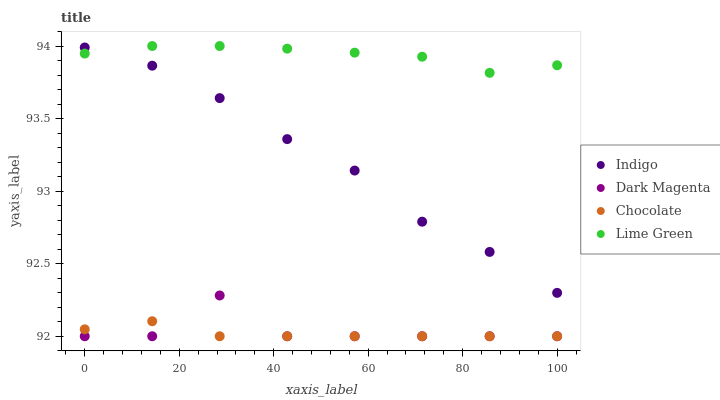Does Chocolate have the minimum area under the curve?
Answer yes or no. Yes. Does Lime Green have the maximum area under the curve?
Answer yes or no. Yes. Does Indigo have the minimum area under the curve?
Answer yes or no. No. Does Indigo have the maximum area under the curve?
Answer yes or no. No. Is Chocolate the smoothest?
Answer yes or no. Yes. Is Dark Magenta the roughest?
Answer yes or no. Yes. Is Indigo the smoothest?
Answer yes or no. No. Is Indigo the roughest?
Answer yes or no. No. Does Dark Magenta have the lowest value?
Answer yes or no. Yes. Does Indigo have the lowest value?
Answer yes or no. No. Does Lime Green have the highest value?
Answer yes or no. Yes. Does Indigo have the highest value?
Answer yes or no. No. Is Chocolate less than Indigo?
Answer yes or no. Yes. Is Lime Green greater than Chocolate?
Answer yes or no. Yes. Does Dark Magenta intersect Chocolate?
Answer yes or no. Yes. Is Dark Magenta less than Chocolate?
Answer yes or no. No. Is Dark Magenta greater than Chocolate?
Answer yes or no. No. Does Chocolate intersect Indigo?
Answer yes or no. No. 